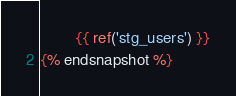Convert code to text. <code><loc_0><loc_0><loc_500><loc_500><_SQL_>        {{ ref('stg_users') }}
{% endsnapshot %}
</code> 